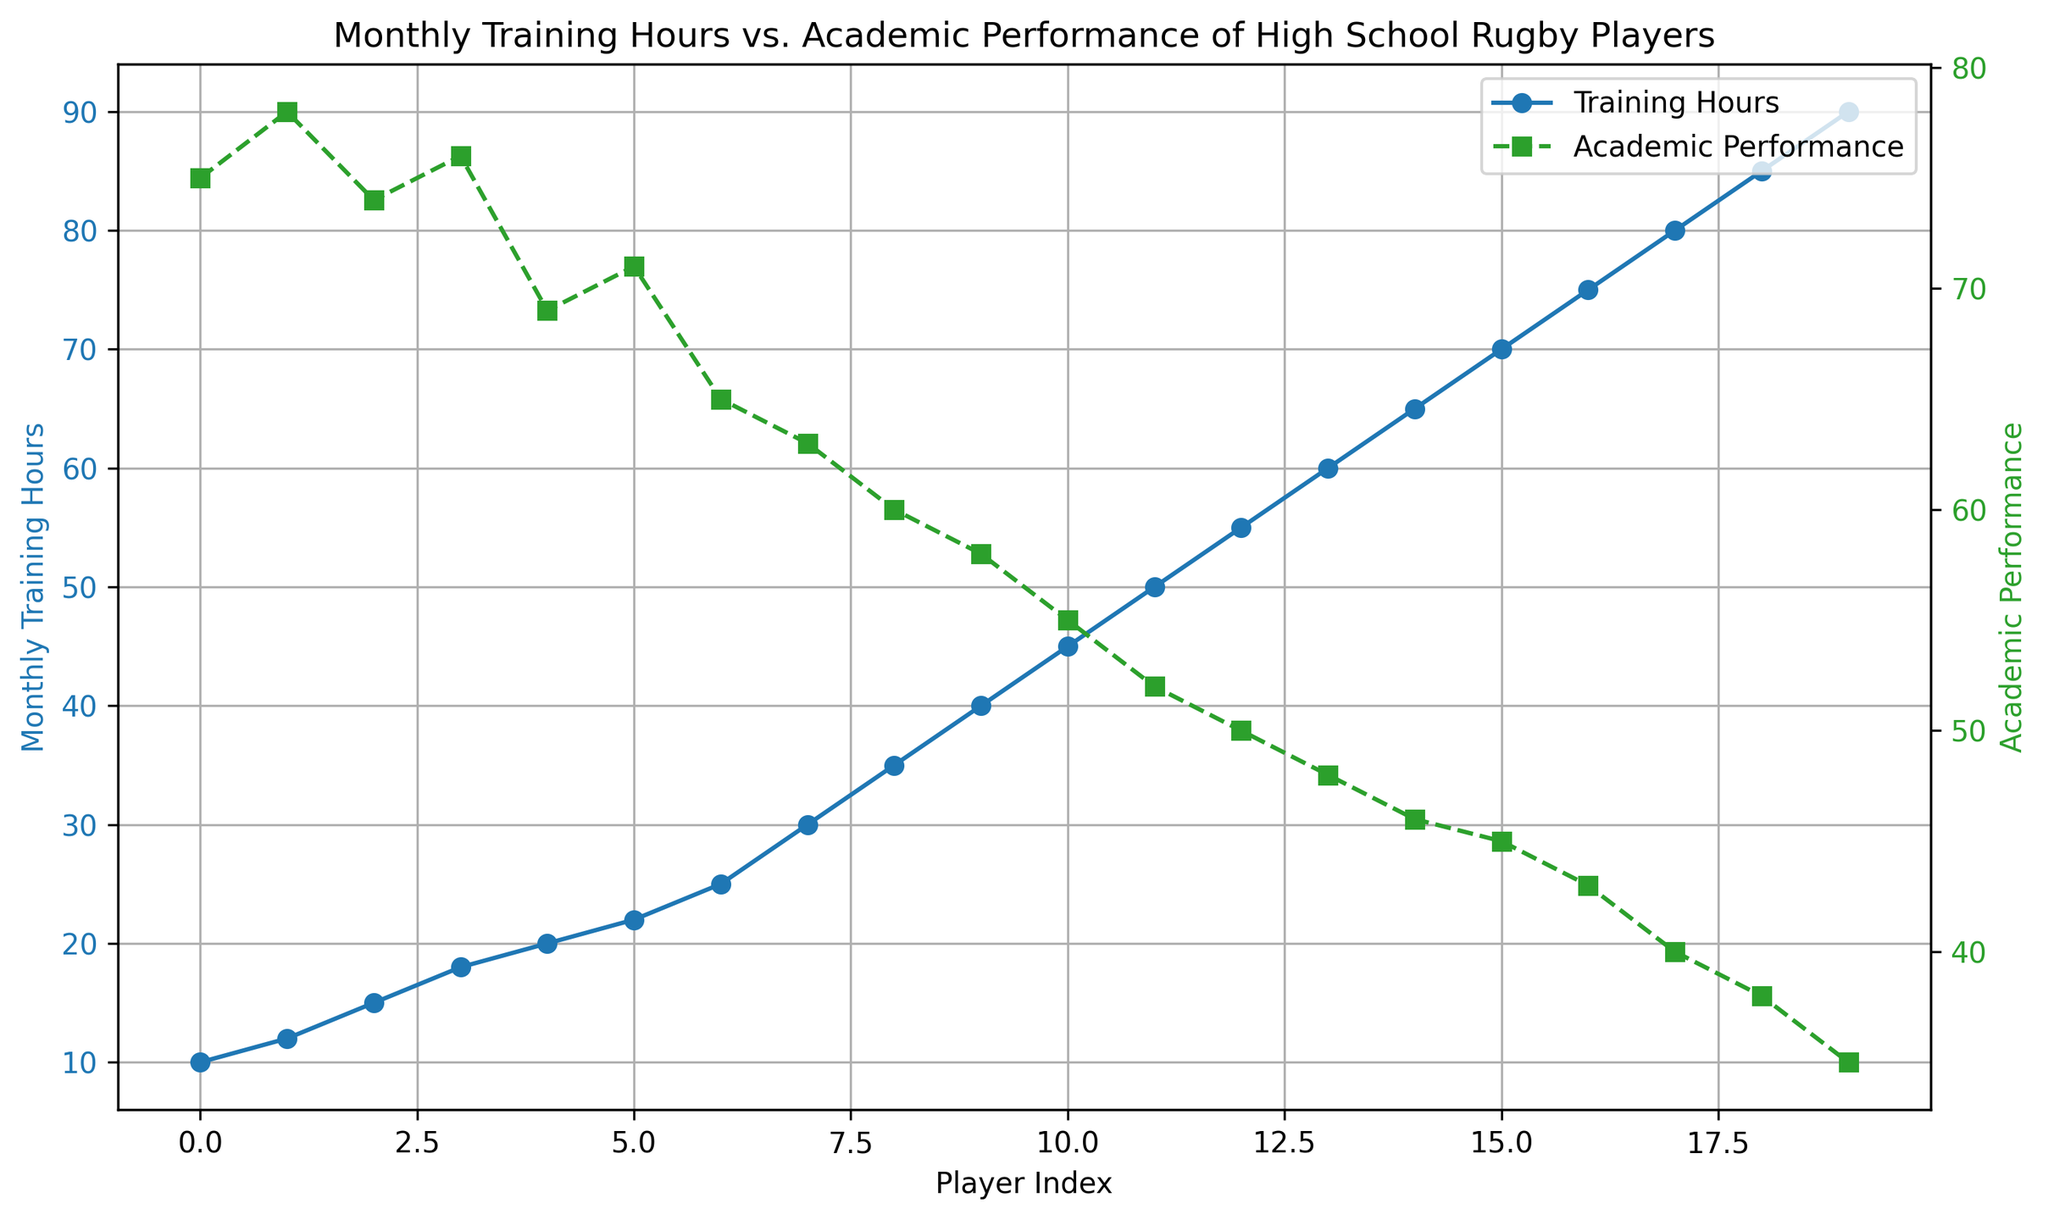What's the trend in academic performance as monthly training hours increase? The plot shows that as the monthly training hours increase, the academic performance tends to decrease. This is evident because the green dashed line representing academic performance slopes downward as the blue line representing training hours slopes upward.
Answer: Decreasing What is the academic performance when the monthly training hours are 40? Locate the point on the primary axis where Monthly Training Hours = 40. Then, look at the corresponding point on the secondary axis for Academic Performance. The green dashed line shows that the academic performance at 40 training hours is 58.
Answer: 58 Compare the monthly training hours for the first and last players in the dataset. The plot for the first player on the primary axis (index 0) shows a Monthly Training Hours value of 10. For the last player (index 19), the Monthly Training Hours value is 90.
Answer: 10 and 90 Which player index shows the highest academic performance, and what is the value? The plot shows several points for academic performance across different player indices. By examining the green dashed line, the highest academic performance on the secondary axis is 78 at player index 1.
Answer: Player index 1, 78 What is the difference in academic performance between player index 10 and player index 15? Locate the academic performance values at player indices 10 and 15 on the green dashed line. At index 10, it is 55, and at index 15, it is 45. Subtract 45 from 55 to find the difference.
Answer: 10 How does the color of the lines help in distinguishing between monthly training hours and academic performance? The blue solid line represents monthly training hours, and the green dashed line represents academic performance. The distinct colors and line styles (solid vs. dashed) help to easily differentiate between the two data sets on the plot.
Answer: By color and line style What is the difference in monthly training hours between player index 6 and 16? Locate the monthly training hours values at player indices 6 and 16 on the blue solid line. At index 6, the value is 25 hours, and at index 16, it is 70 hours. Subtract 25 from 70 to find the difference.
Answer: 45 hours Identify player indices where both monthly training hours and academic performance show a downward trend. Observe the plot and locate segments where both the blue solid line and the green dashed line are decreasing. This occurs continuously across most player indices, but specifically notable from index 4 onwards.
Answer: From index 4 onwards What is the average academic performance for the first 5 players? Identify the academic performance values for the first 5 player indices (0 to 4) on the green dashed line: 75, 78, 74, 76, and 69. Sum these values: 75 + 78 + 74 + 76 + 69 = 372. Divide by 5 to find the average: 372/5 = 74.4
Answer: 74.4 